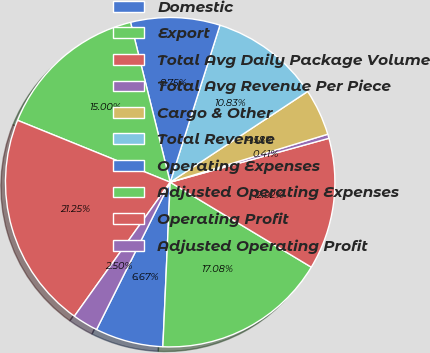<chart> <loc_0><loc_0><loc_500><loc_500><pie_chart><fcel>Domestic<fcel>Export<fcel>Total Avg Daily Package Volume<fcel>Total Avg Revenue Per Piece<fcel>Cargo & Other<fcel>Total Revenue<fcel>Operating Expenses<fcel>Adjusted Operating Expenses<fcel>Operating Profit<fcel>Adjusted Operating Profit<nl><fcel>6.67%<fcel>17.08%<fcel>12.92%<fcel>0.41%<fcel>4.58%<fcel>10.83%<fcel>8.75%<fcel>15.0%<fcel>21.25%<fcel>2.5%<nl></chart> 